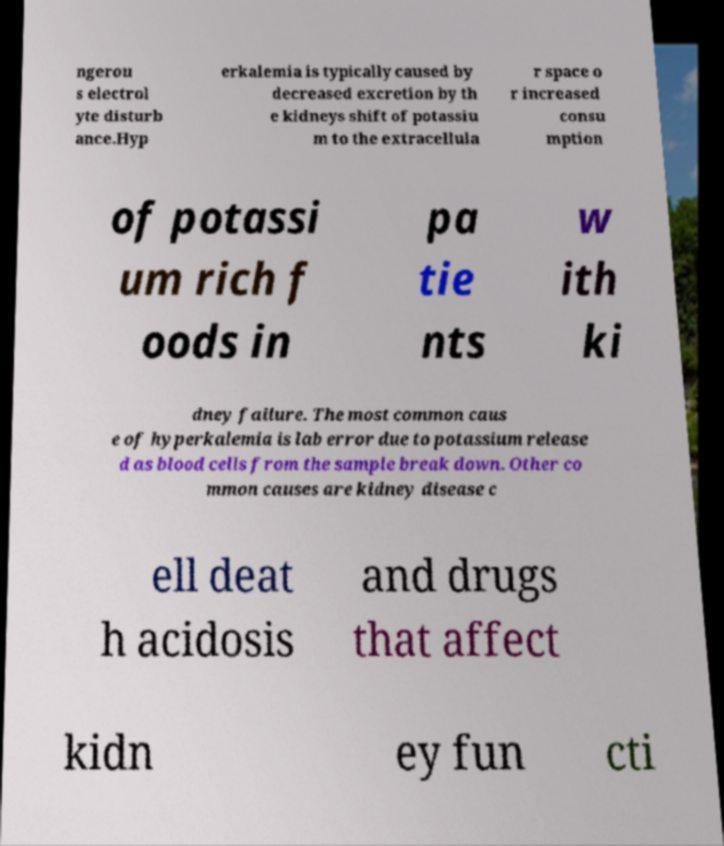For documentation purposes, I need the text within this image transcribed. Could you provide that? ngerou s electrol yte disturb ance.Hyp erkalemia is typically caused by decreased excretion by th e kidneys shift of potassiu m to the extracellula r space o r increased consu mption of potassi um rich f oods in pa tie nts w ith ki dney failure. The most common caus e of hyperkalemia is lab error due to potassium release d as blood cells from the sample break down. Other co mmon causes are kidney disease c ell deat h acidosis and drugs that affect kidn ey fun cti 